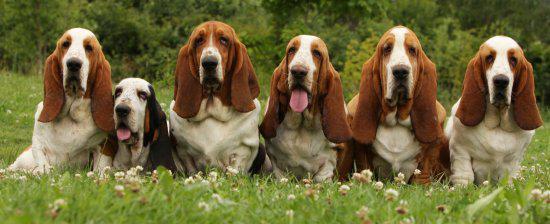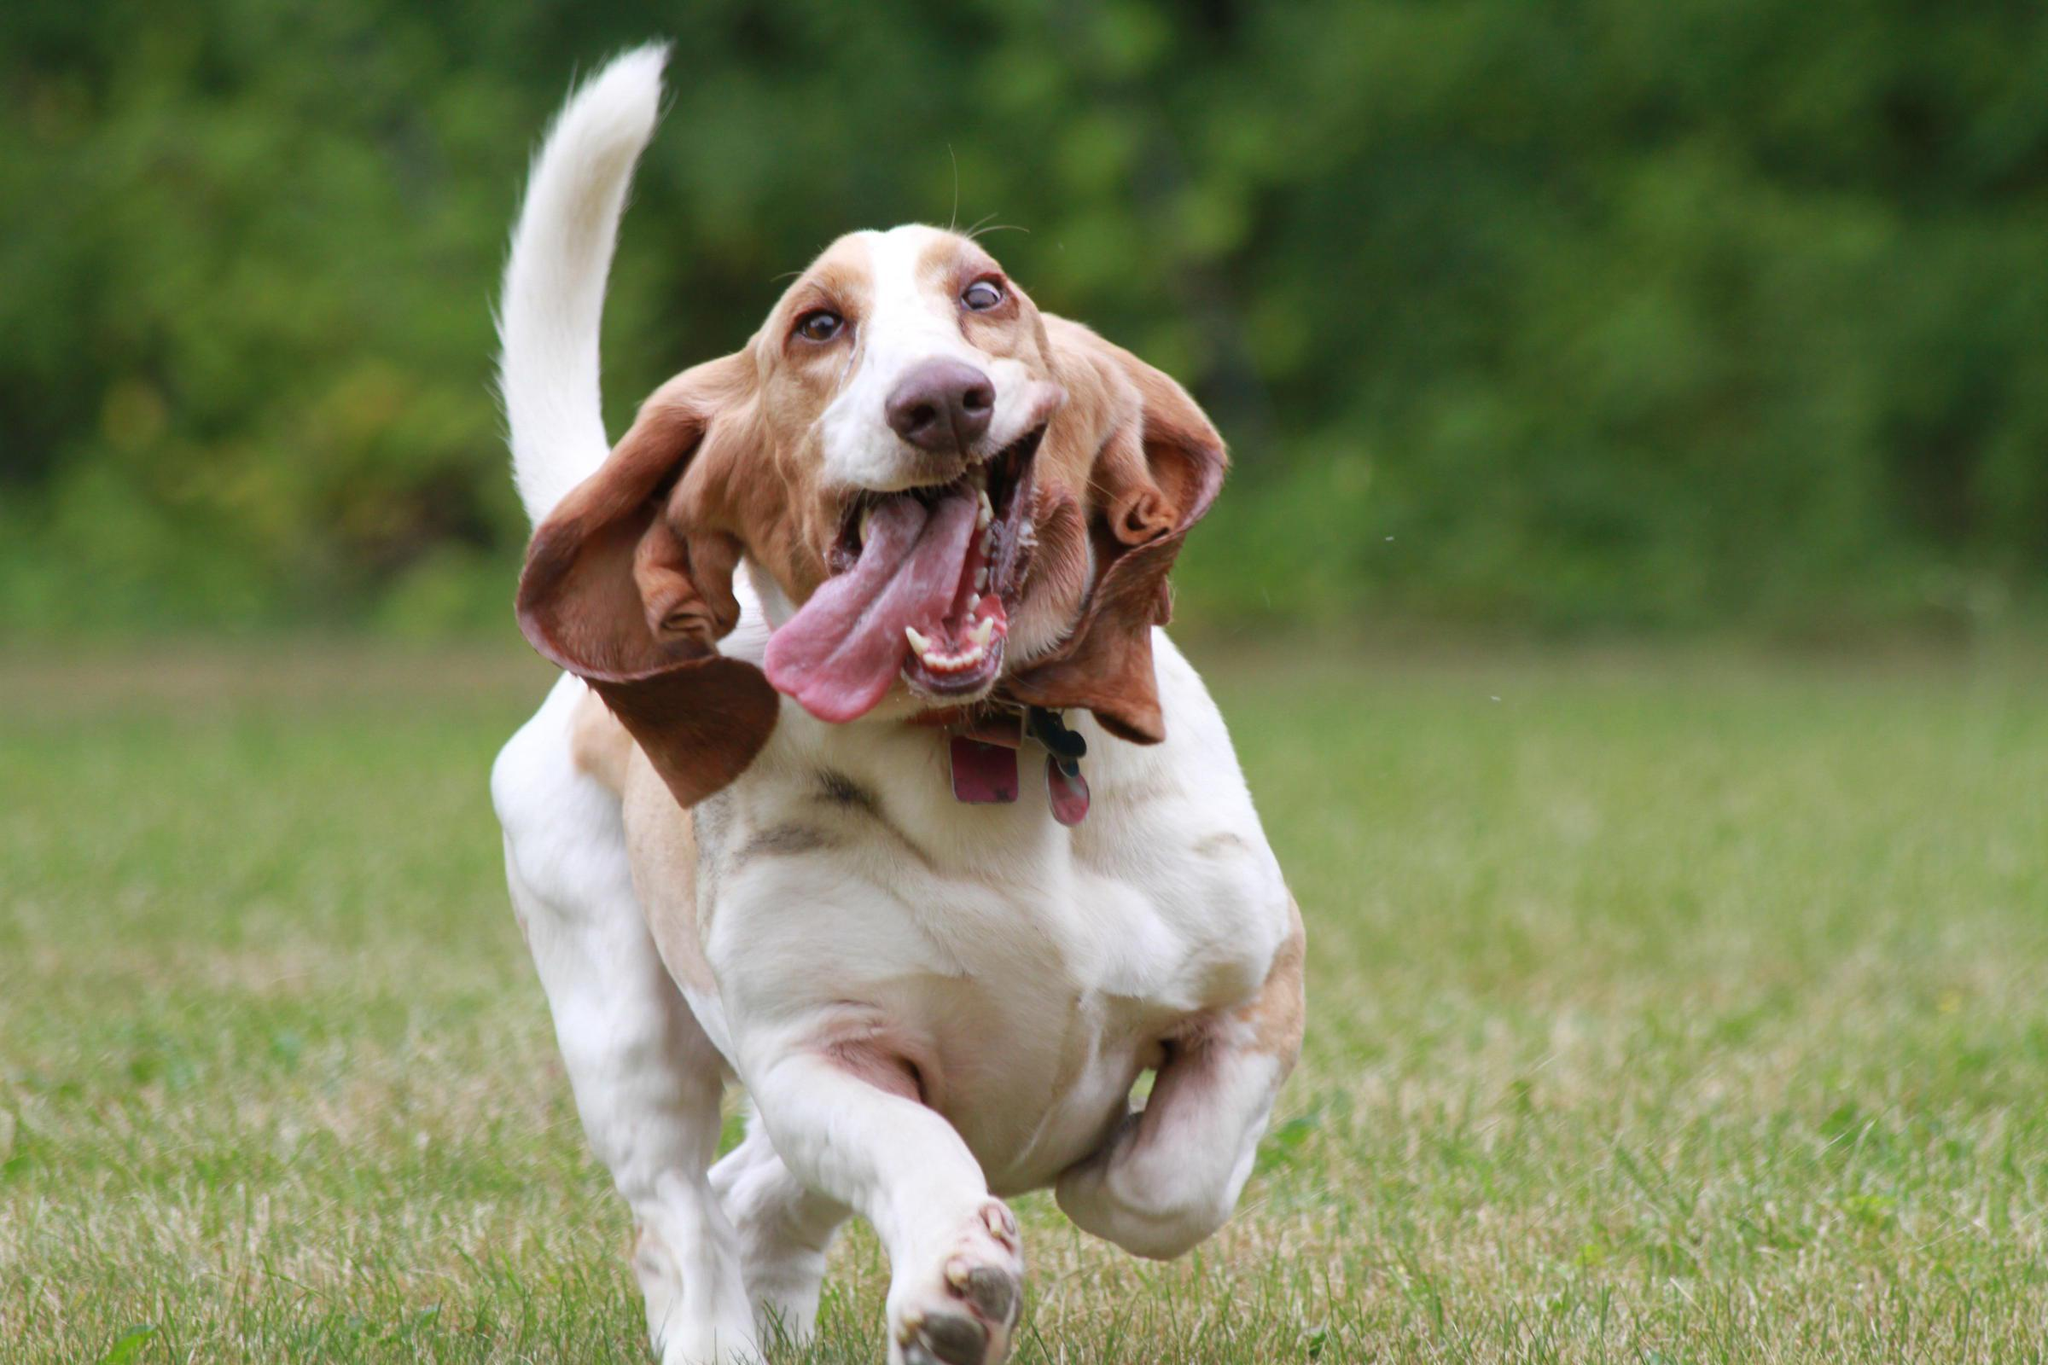The first image is the image on the left, the second image is the image on the right. Evaluate the accuracy of this statement regarding the images: "One of the dogs is running in the grass.". Is it true? Answer yes or no. Yes. The first image is the image on the left, the second image is the image on the right. Assess this claim about the two images: "One image shows a basset in profile on a white background.". Correct or not? Answer yes or no. No. 